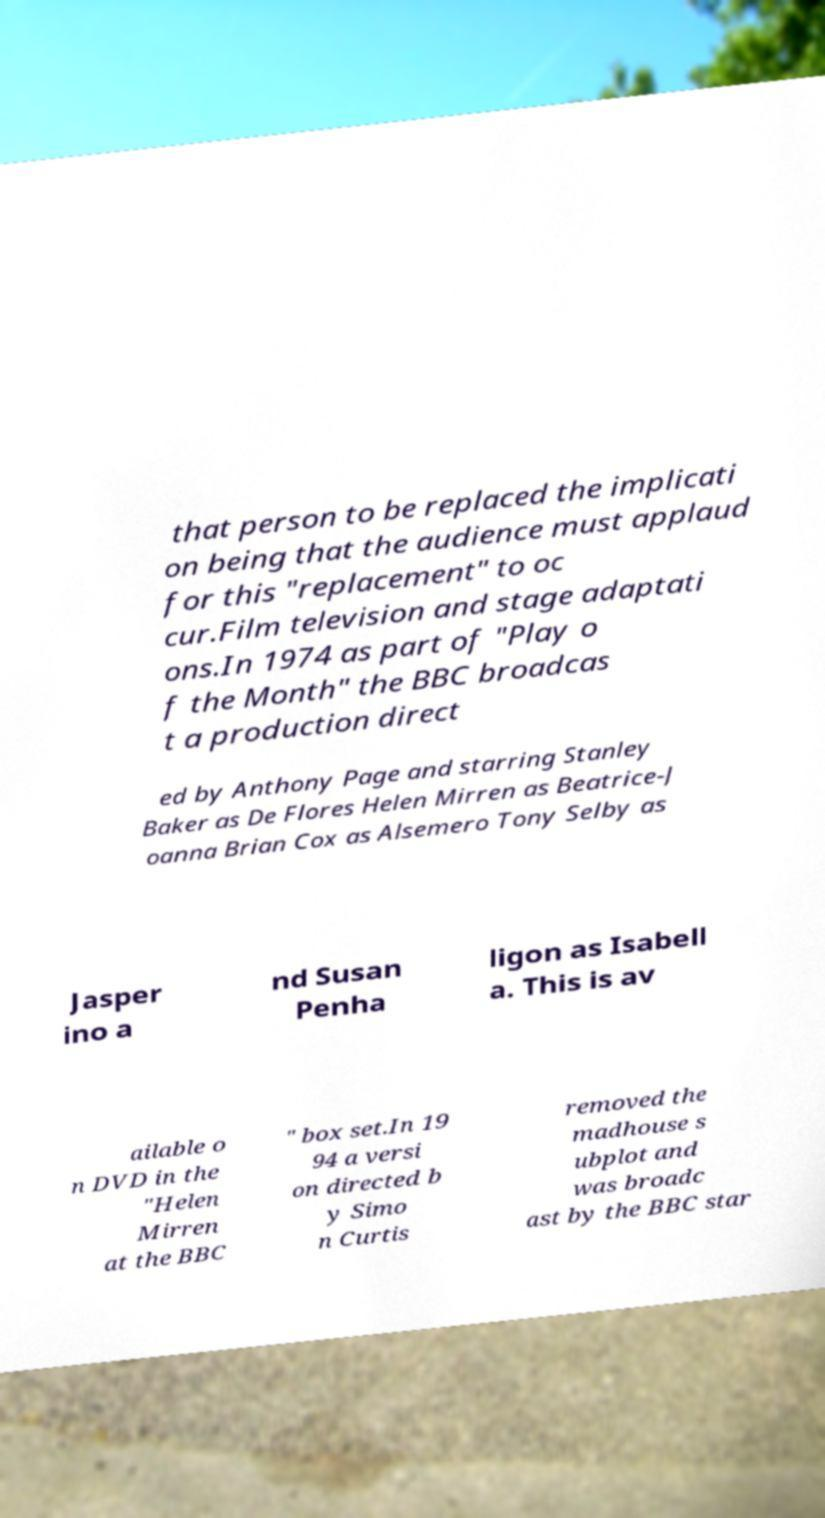Please read and relay the text visible in this image. What does it say? that person to be replaced the implicati on being that the audience must applaud for this "replacement" to oc cur.Film television and stage adaptati ons.In 1974 as part of "Play o f the Month" the BBC broadcas t a production direct ed by Anthony Page and starring Stanley Baker as De Flores Helen Mirren as Beatrice-J oanna Brian Cox as Alsemero Tony Selby as Jasper ino a nd Susan Penha ligon as Isabell a. This is av ailable o n DVD in the "Helen Mirren at the BBC " box set.In 19 94 a versi on directed b y Simo n Curtis removed the madhouse s ubplot and was broadc ast by the BBC star 